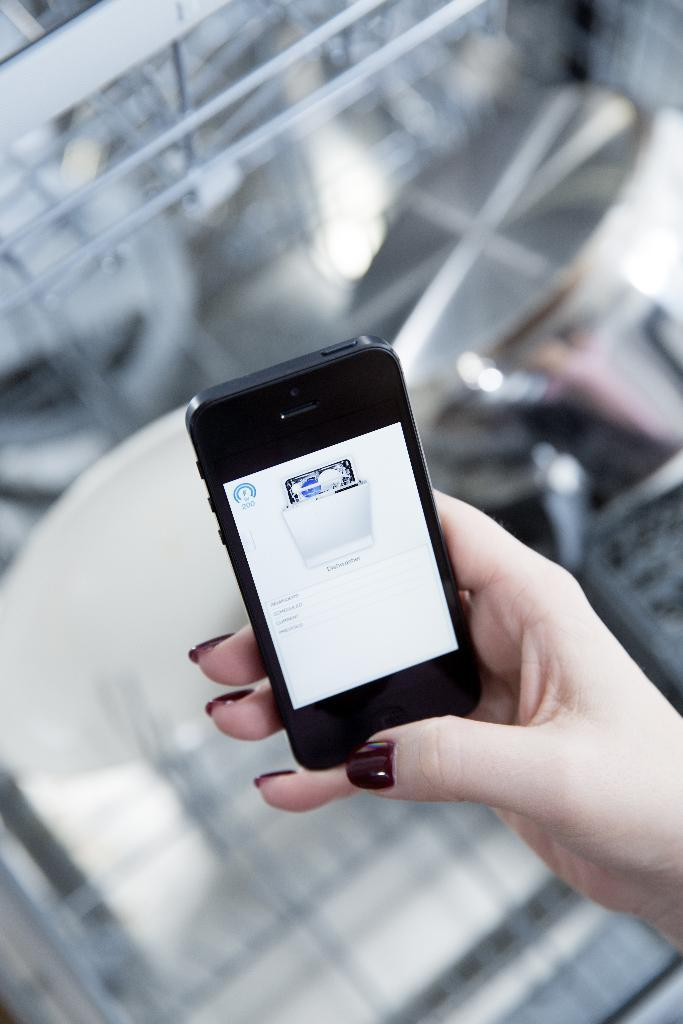What is being held by the person's hand in the image? A person's hand is holding a mobile in the image. What can be seen in the background of the image? There are rods and some objects in the background of the image. How would you describe the appearance of the background? The background is blurry. What type of pencil can be seen in the image? There is no pencil present in the image. Is the background obscured by fog in the image? The background is blurry, but there is no mention of fog in the image. 